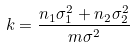Convert formula to latex. <formula><loc_0><loc_0><loc_500><loc_500>k = \frac { n _ { 1 } \sigma _ { 1 } ^ { 2 } + n _ { 2 } \sigma _ { 2 } ^ { 2 } } { m \sigma ^ { 2 } }</formula> 